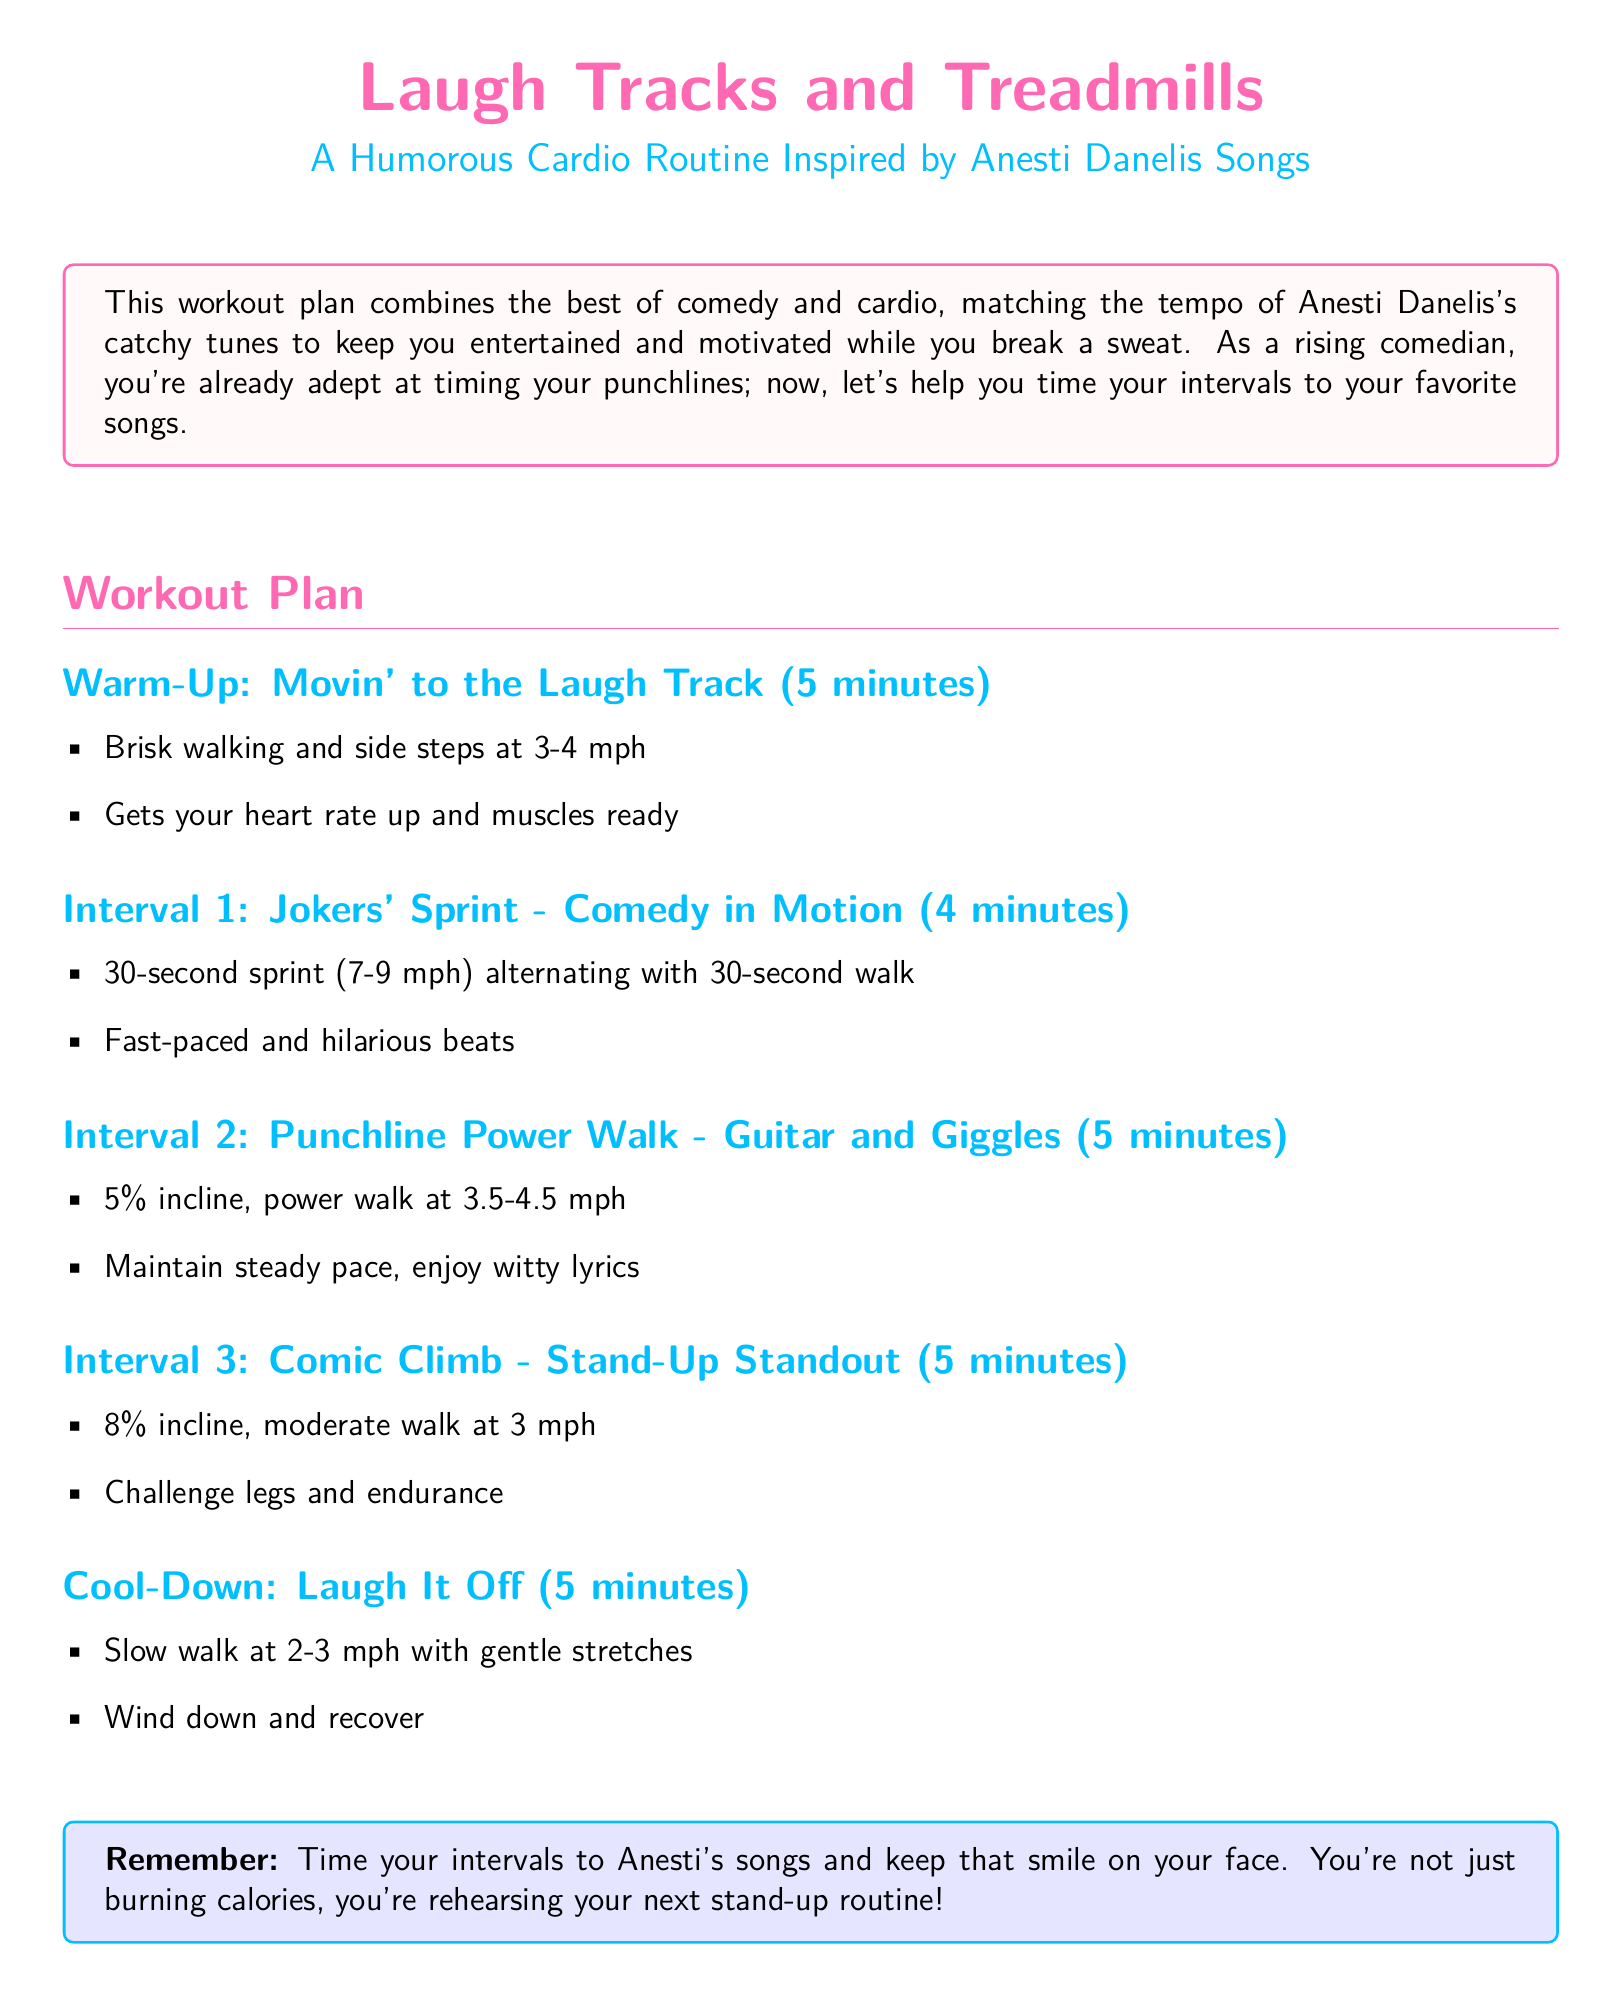What is the title of the workout plan? The title of the workout plan is stated prominently at the top of the document.
Answer: Laugh Tracks and Treadmills How long is the warm-up section? The warm-up section's duration is specified directly in the plan.
Answer: 5 minutes What is the speed of the sprint in Interval 1? The speed for the sprint is mentioned as a range in Interval 1.
Answer: 7-9 mph What incline is used in Interval 2? The incline for Interval 2 is detailed clearly in the workout plan.
Answer: 5% What is the total duration of the workout plan? The document lists the duration for each section, allowing calculation of the total time.
Answer: 24 minutes Which exercise involves a challenge for legs and endurance? The exercise that specifically challenges legs and endurance is highlighted in Interval 3.
Answer: Comic Climb What is the cooling-down exercise? The cool-down exercise is stated at the end of the workout plan.
Answer: Laugh It Off What should you do during the cool-down? The cool-down instructions are described in the final section of the workout plan.
Answer: Slow walk and gentle stretches How does the workout incorporate Anesti Danelis's songs? The document explains how to time intervals to the songs for motivation.
Answer: Time your intervals to Anesti’s songs 